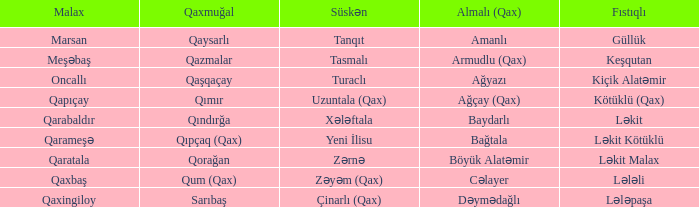What is the Almali village with the Malax village qaxingiloy? Dəymədağlı. 